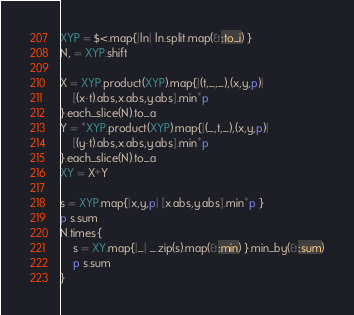<code> <loc_0><loc_0><loc_500><loc_500><_Ruby_>XYP = $<.map{|ln| ln.split.map(&:to_i) }
N, = XYP.shift

X = XYP.product(XYP).map{|(t,_,_),(x,y,p)|
	[(x-t).abs,x.abs,y.abs].min*p
}.each_slice(N).to_a
Y = *XYP.product(XYP).map{|(_,t,_),(x,y,p)|
	[(y-t).abs,x.abs,y.abs].min*p
}.each_slice(N).to_a
XY = X+Y

s = XYP.map{|x,y,p| [x.abs,y.abs].min*p }
p s.sum
N.times{
	s = XY.map{|_| _.zip(s).map(&:min) }.min_by(&:sum)
	p s.sum
}
</code> 